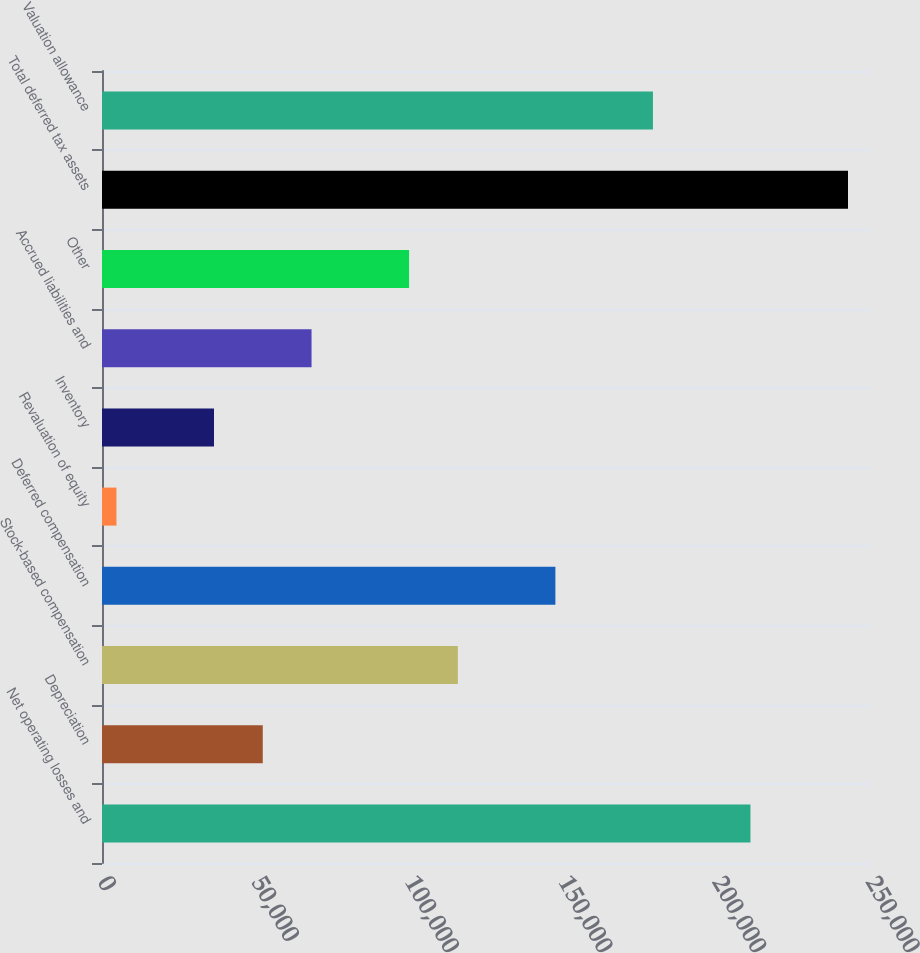<chart> <loc_0><loc_0><loc_500><loc_500><bar_chart><fcel>Net operating losses and<fcel>Depreciation<fcel>Stock-based compensation<fcel>Deferred compensation<fcel>Revaluation of equity<fcel>Inventory<fcel>Accrued liabilities and<fcel>Other<fcel>Total deferred tax assets<fcel>Valuation allowance<nl><fcel>211090<fcel>52333.8<fcel>115836<fcel>147587<fcel>4707<fcel>36458.2<fcel>68209.4<fcel>99960.6<fcel>242841<fcel>179339<nl></chart> 